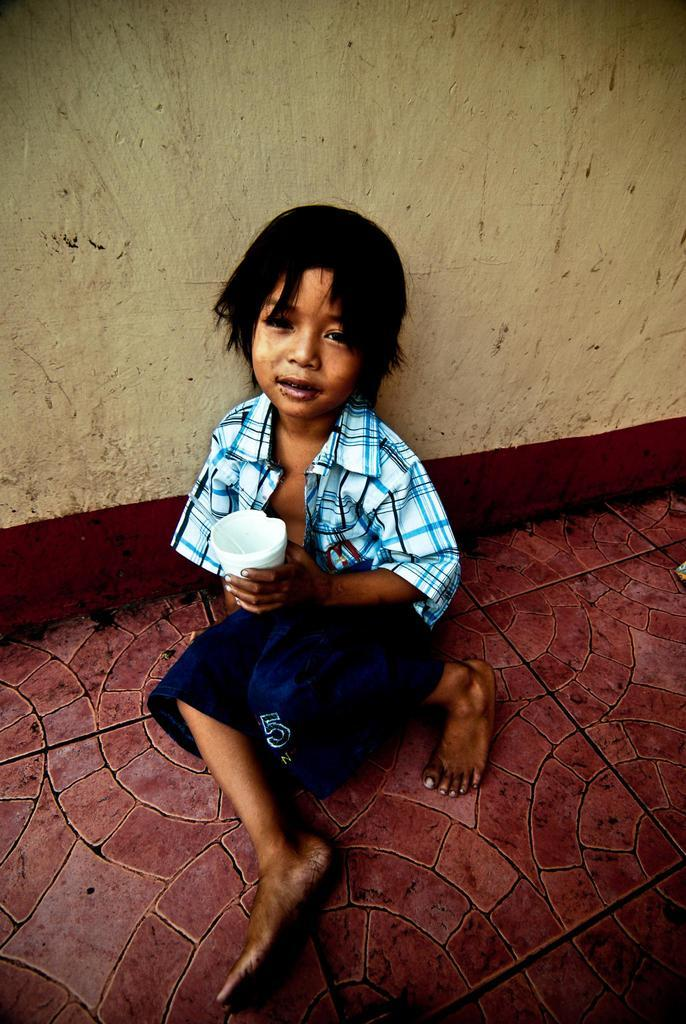Who is the main subject in the image? There is a boy in the image. Where is the boy located in the image? The boy is sitting in the middle of the image. What is the boy wearing? The boy is wearing a shirt and shorts. What is the boy holding in his hand? The boy is holding a glass with his hand. What type of agreement is the boy signing in the image? There is no agreement or signing activity present in the image. 